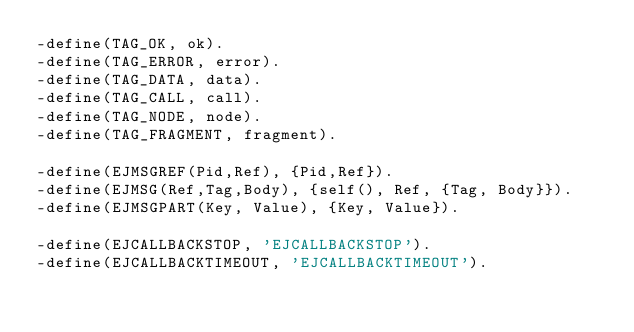<code> <loc_0><loc_0><loc_500><loc_500><_Erlang_>-define(TAG_OK, ok).
-define(TAG_ERROR, error).
-define(TAG_DATA, data).
-define(TAG_CALL, call).
-define(TAG_NODE, node).
-define(TAG_FRAGMENT, fragment).

-define(EJMSGREF(Pid,Ref), {Pid,Ref}).
-define(EJMSG(Ref,Tag,Body), {self(), Ref, {Tag, Body}}).
-define(EJMSGPART(Key, Value), {Key, Value}).

-define(EJCALLBACKSTOP, 'EJCALLBACKSTOP').
-define(EJCALLBACKTIMEOUT, 'EJCALLBACKTIMEOUT').</code> 